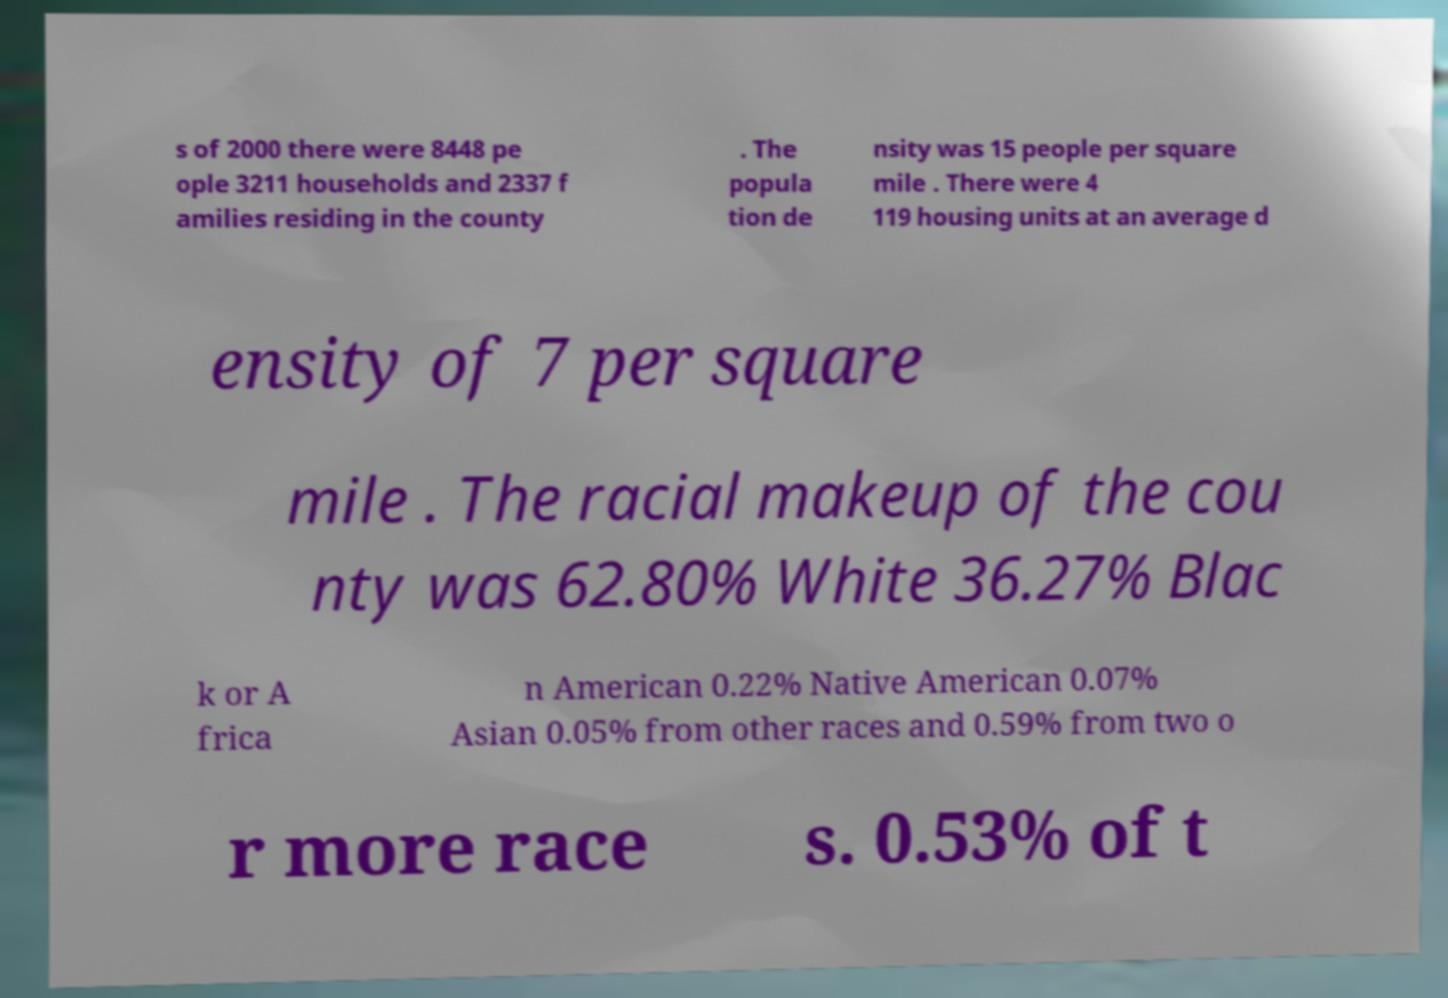I need the written content from this picture converted into text. Can you do that? s of 2000 there were 8448 pe ople 3211 households and 2337 f amilies residing in the county . The popula tion de nsity was 15 people per square mile . There were 4 119 housing units at an average d ensity of 7 per square mile . The racial makeup of the cou nty was 62.80% White 36.27% Blac k or A frica n American 0.22% Native American 0.07% Asian 0.05% from other races and 0.59% from two o r more race s. 0.53% of t 